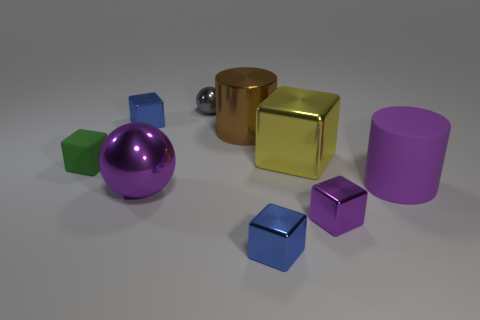Subtract all yellow metallic blocks. How many blocks are left? 4 Subtract all gray spheres. How many spheres are left? 1 Subtract all cyan balls. How many red cylinders are left? 0 Subtract 1 cylinders. How many cylinders are left? 1 Subtract all red blocks. Subtract all purple cylinders. How many blocks are left? 5 Subtract all gray metal objects. Subtract all gray shiny objects. How many objects are left? 7 Add 6 gray metal things. How many gray metal things are left? 7 Add 5 small green blocks. How many small green blocks exist? 6 Subtract 1 gray balls. How many objects are left? 8 Subtract all spheres. How many objects are left? 7 